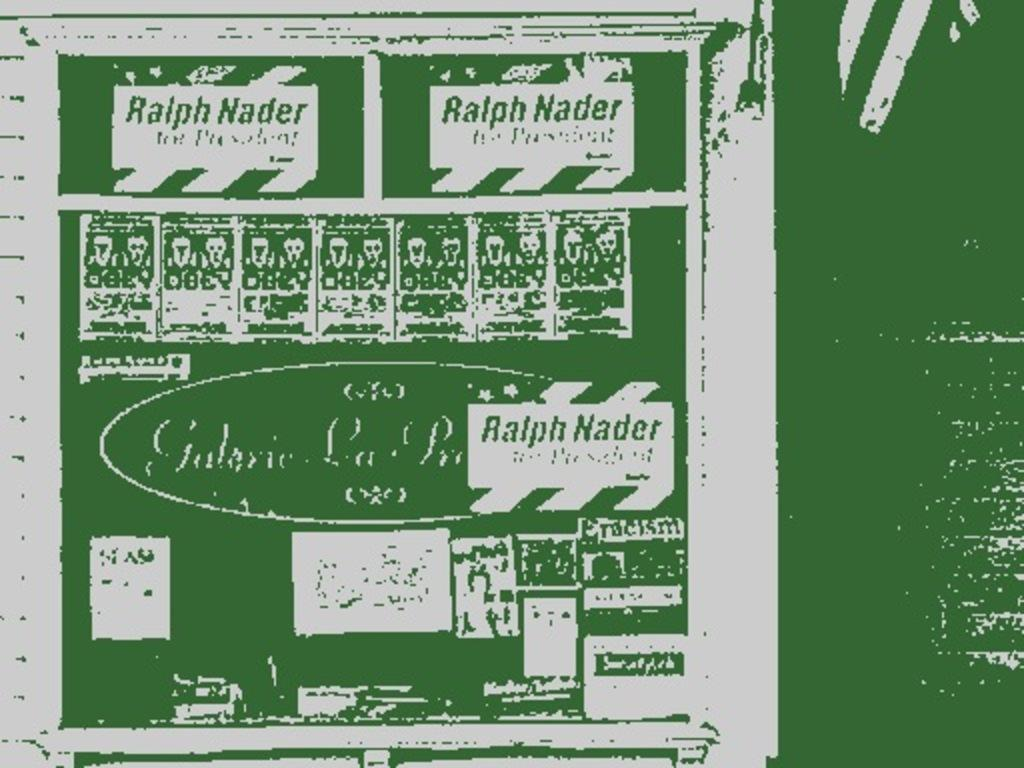<image>
Create a compact narrative representing the image presented. A green messed up looking post card that says Ralph Nader on it. 